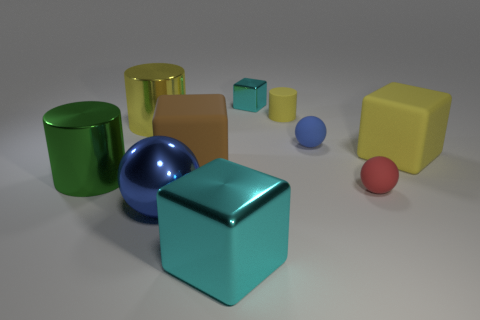What number of matte objects are the same color as the tiny matte cylinder?
Give a very brief answer. 1. Is the large metallic cube the same color as the tiny shiny object?
Offer a terse response. Yes. How many yellow matte cubes are there?
Provide a succinct answer. 1. Are the cylinder that is to the right of the large cyan metal thing and the large yellow object that is on the right side of the small yellow matte cylinder made of the same material?
Your response must be concise. Yes. The other tiny object that is the same shape as the tiny red object is what color?
Your answer should be very brief. Blue. The tiny sphere that is in front of the blue sphere behind the big yellow block is made of what material?
Provide a succinct answer. Rubber. There is a blue thing on the right side of the brown matte block; is its shape the same as the object behind the small yellow cylinder?
Provide a succinct answer. No. What is the size of the block that is both behind the brown cube and on the left side of the tiny yellow thing?
Your answer should be very brief. Small. How many other objects are the same color as the small cylinder?
Make the answer very short. 2. Do the large yellow object on the left side of the metallic ball and the green cylinder have the same material?
Give a very brief answer. Yes. 